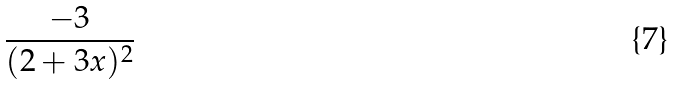Convert formula to latex. <formula><loc_0><loc_0><loc_500><loc_500>\frac { - 3 } { ( 2 + 3 x ) ^ { 2 } }</formula> 